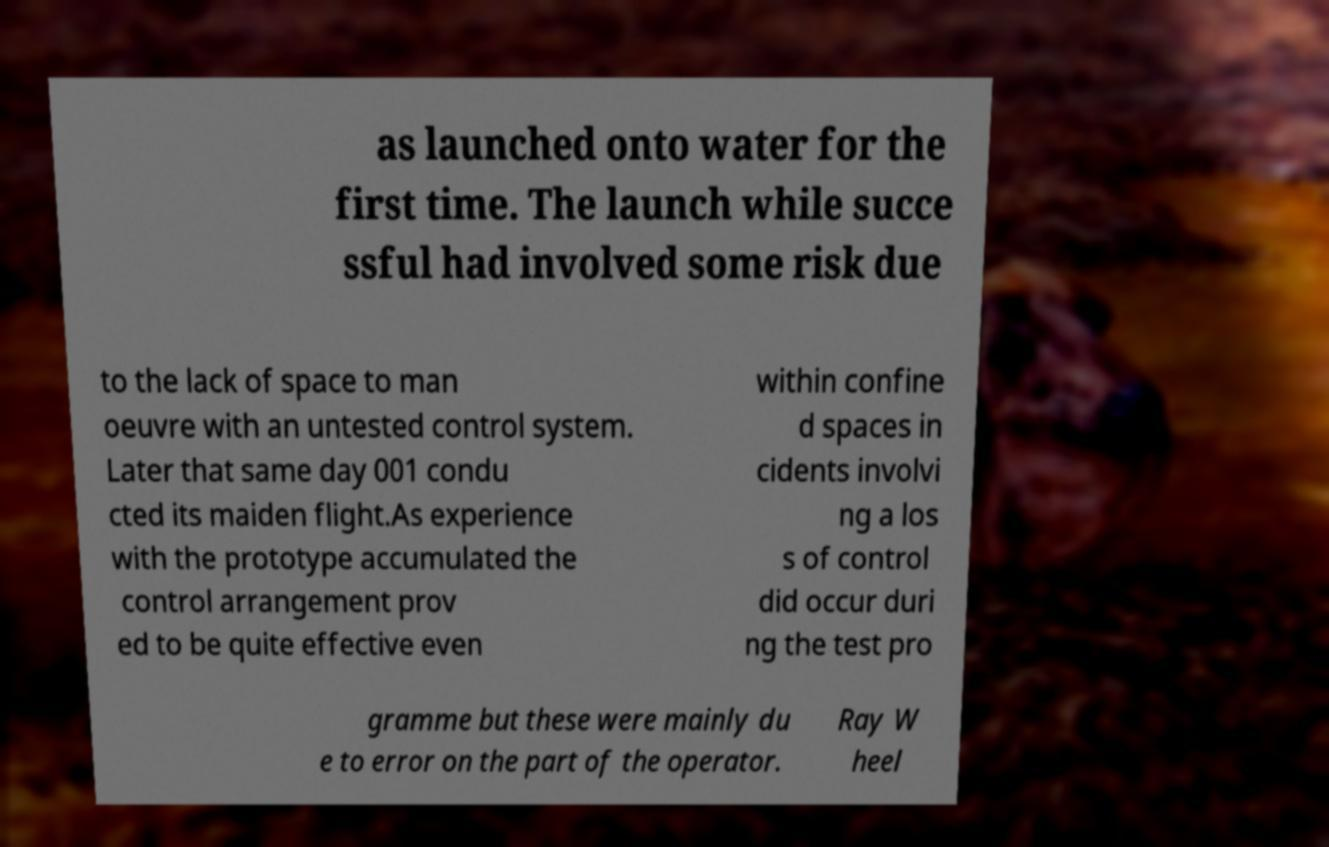I need the written content from this picture converted into text. Can you do that? as launched onto water for the first time. The launch while succe ssful had involved some risk due to the lack of space to man oeuvre with an untested control system. Later that same day 001 condu cted its maiden flight.As experience with the prototype accumulated the control arrangement prov ed to be quite effective even within confine d spaces in cidents involvi ng a los s of control did occur duri ng the test pro gramme but these were mainly du e to error on the part of the operator. Ray W heel 